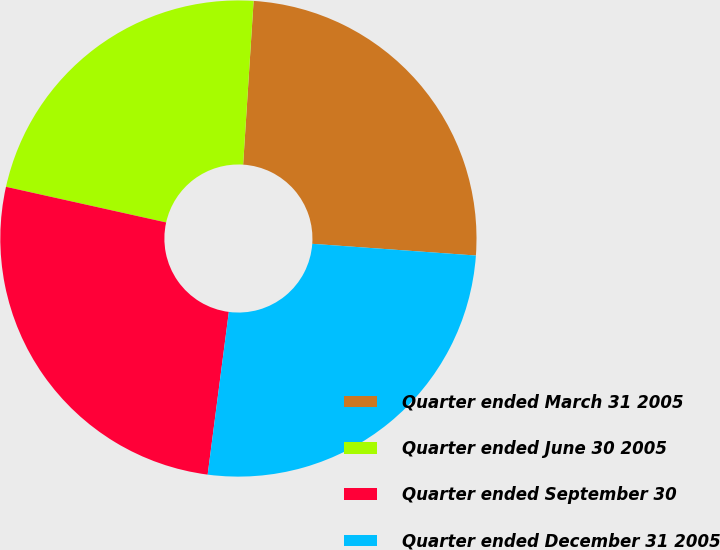<chart> <loc_0><loc_0><loc_500><loc_500><pie_chart><fcel>Quarter ended March 31 2005<fcel>Quarter ended June 30 2005<fcel>Quarter ended September 30<fcel>Quarter ended December 31 2005<nl><fcel>25.12%<fcel>22.53%<fcel>26.42%<fcel>25.92%<nl></chart> 